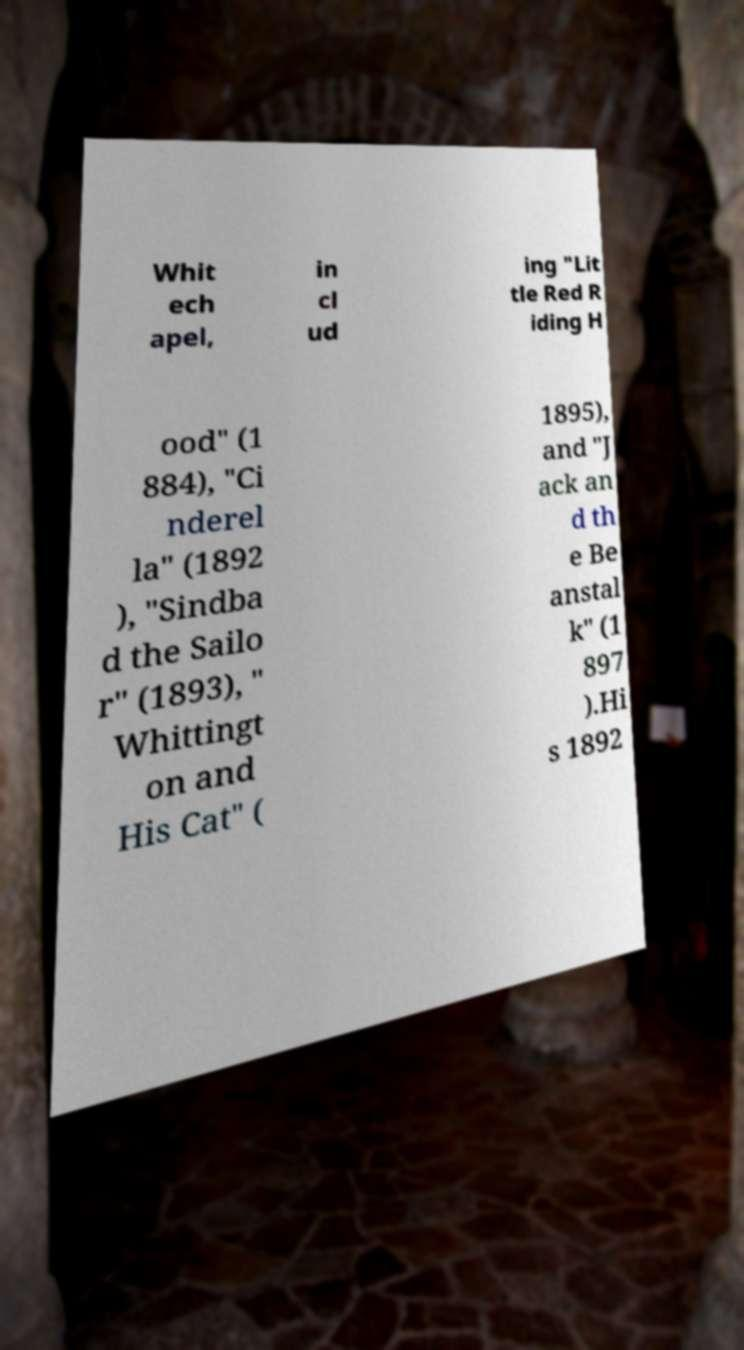I need the written content from this picture converted into text. Can you do that? Whit ech apel, in cl ud ing "Lit tle Red R iding H ood" (1 884), "Ci nderel la" (1892 ), "Sindba d the Sailo r" (1893), " Whittingt on and His Cat" ( 1895), and "J ack an d th e Be anstal k" (1 897 ).Hi s 1892 